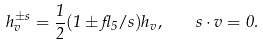Convert formula to latex. <formula><loc_0><loc_0><loc_500><loc_500>h _ { v } ^ { \pm s } = \frac { 1 } { 2 } ( 1 \pm \gamma _ { 5 } \slash { s } ) h _ { v } , \quad s \cdot v = 0 .</formula> 